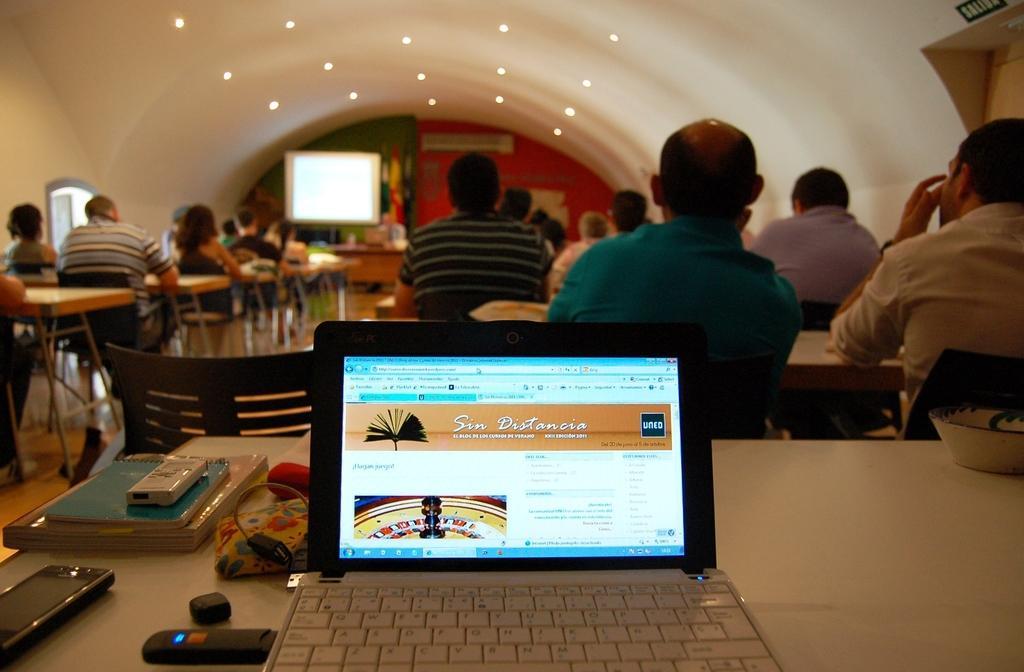Please provide a concise description of this image. In this picture we can see laptop, mobile, books which are on table, there are some persons sitting on chairs and in the background of the picture there is projector screen. 